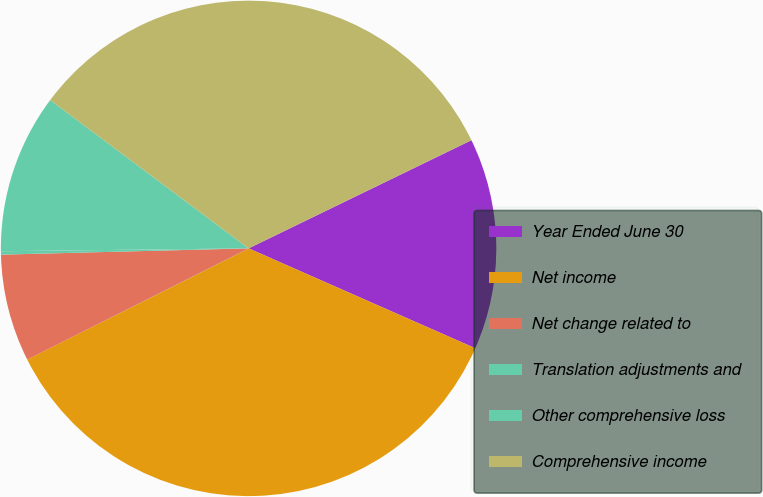Convert chart to OTSL. <chart><loc_0><loc_0><loc_500><loc_500><pie_chart><fcel>Year Ended June 30<fcel>Net income<fcel>Net change related to<fcel>Translation adjustments and<fcel>Other comprehensive loss<fcel>Comprehensive income<nl><fcel>13.8%<fcel>35.98%<fcel>7.01%<fcel>0.22%<fcel>10.4%<fcel>32.59%<nl></chart> 